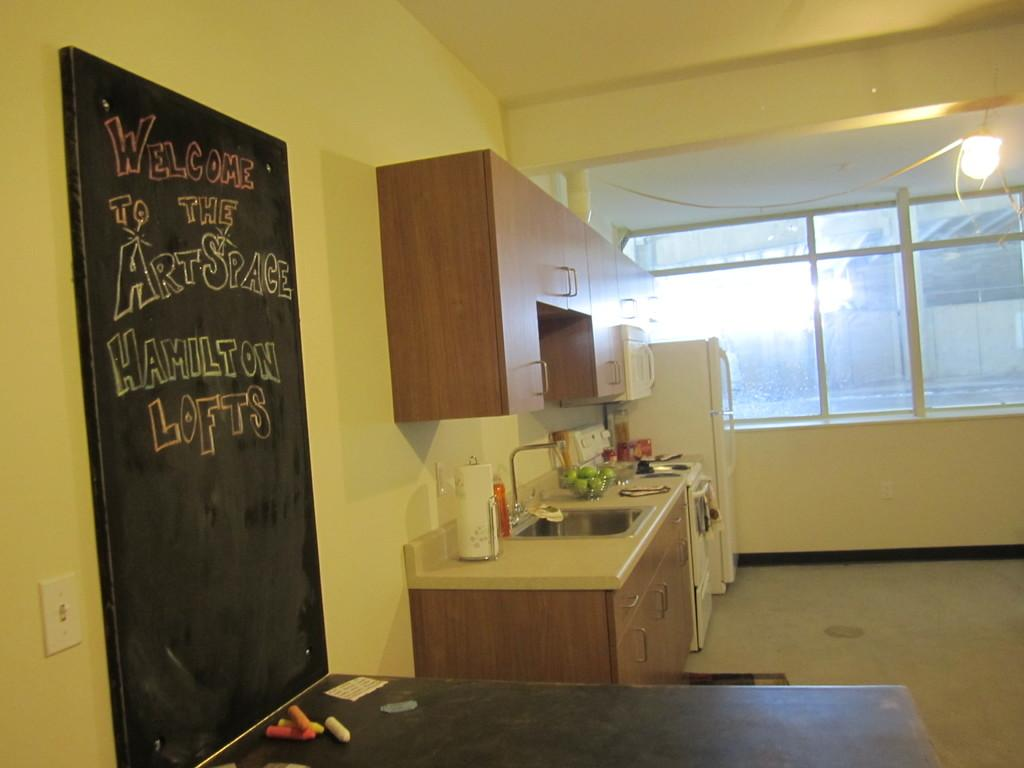<image>
Present a compact description of the photo's key features. Someone has written "welcome to the art space" on the chalkboard in this room. 